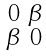<formula> <loc_0><loc_0><loc_500><loc_500>\begin{smallmatrix} 0 & \beta \\ \beta & 0 \end{smallmatrix}</formula> 